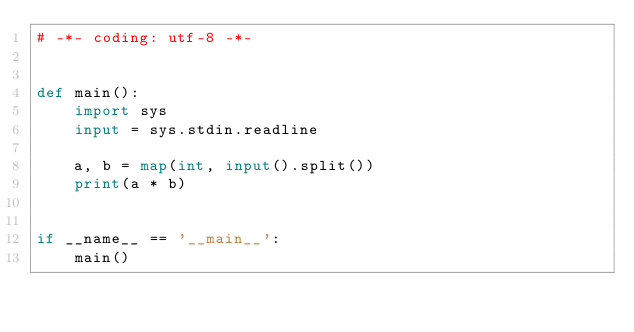Convert code to text. <code><loc_0><loc_0><loc_500><loc_500><_Python_># -*- coding: utf-8 -*-


def main():
    import sys
    input = sys.stdin.readline

    a, b = map(int, input().split())
    print(a * b)


if __name__ == '__main__':
    main()
</code> 